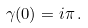Convert formula to latex. <formula><loc_0><loc_0><loc_500><loc_500>\gamma ( 0 ) = i \pi \, .</formula> 